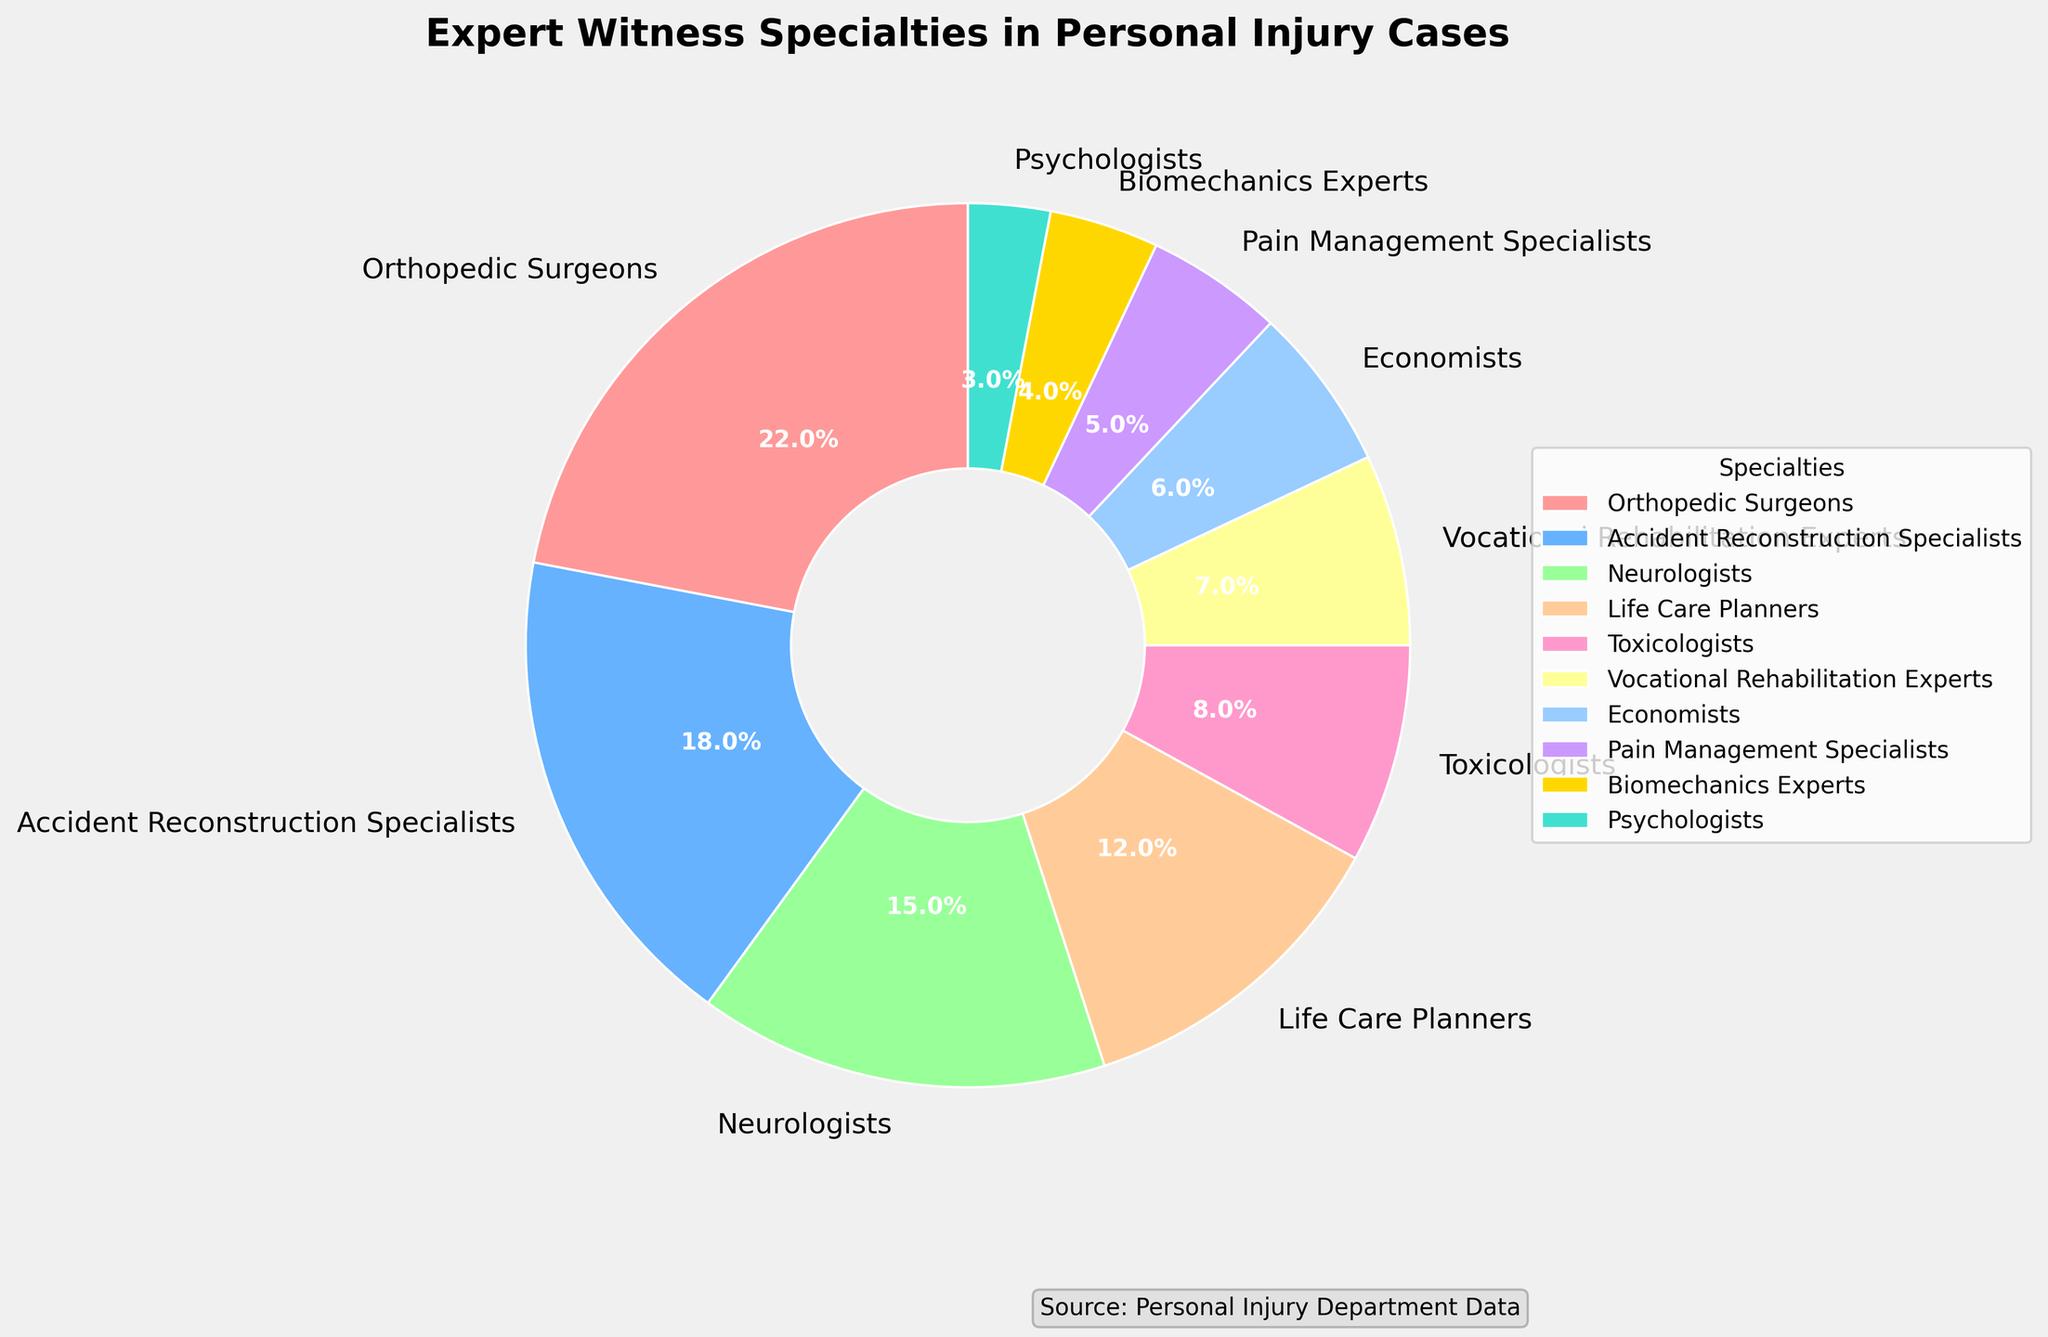What's the total percentage of expert witnesses categorized under medical specialties (Orthopedic Surgeons, Neurologists, Pain Management Specialists, Psychologists)? Sum the percentages of Orthopedic Surgeons (22%), Neurologists (15%), Pain Management Specialists (5%), and Psychologists (3%): 22 + 15 + 5 + 3 = 45%
Answer: 45% Which expert witness specialty has the largest percentage? The largest segment in the pie chart correlates to Orthopedic Surgeons, which is labeled as 22%.
Answer: Orthopedic Surgeons What is the combined percentage of Accident Reconstruction Specialists and Life Care Planners? Sum the percentages of Accident Reconstruction Specialists (18%) and Life Care Planners (12%): 18 + 12 = 30%
Answer: 30% Are there more Economists or Biomechanics Experts used as expert witnesses? Compare the wedge sizes and the labels: Economists are at 6% while Biomechanics Experts are at 4%.
Answer: Economists What's the percentage difference between the highest and the lowest specialties? Identify the highest (Orthopedic Surgeons, 22%) and the lowest (Psychologists, 3%), then subtract: 22 - 3 = 19%
Answer: 19% Which group of specialties (Orthopedic Surgeons, Accident Reconstruction Specialists, Neurologists) vs. (Toxicologists, Vocational Rehabilitation Experts, Economists) has a higher total percentage? Sum the first group: 22 + 18 + 15 = 55%. Sum the second group: 8 + 7 + 6 = 21%. Compare the sums: 55% vs. 21%.
Answer: First group What fraction of the pie chart represents Pain Management Specialists? Pain Management Specialists have 5%, which is equal to 5 out of 100, or 1/20 of the entire chart.
Answer: 1/20 Does any single specialty contribute more than a quarter of the entire pie chart? Identify whether any wedge exceeds 25%. The highest percentage is Orthopedic Surgeons with 22%, which is less than a quarter (25%).
Answer: No What is the visual representation color of Vocational Rehabilitation Experts? Locate the segment labeled "Vocational Rehabilitation Experts" and identify its color, which is a yellowish hue.
Answer: Yellowish How many specialties have percentages below 10%? Count the labeled segments with percentages lower than 10%: Toxicologists (8%), Vocational Rehabilitation Experts (7%), Economists (6%), Pain Management Specialists (5%), Biomechanics Experts (4%), Psychologists (3%).
Answer: 6 